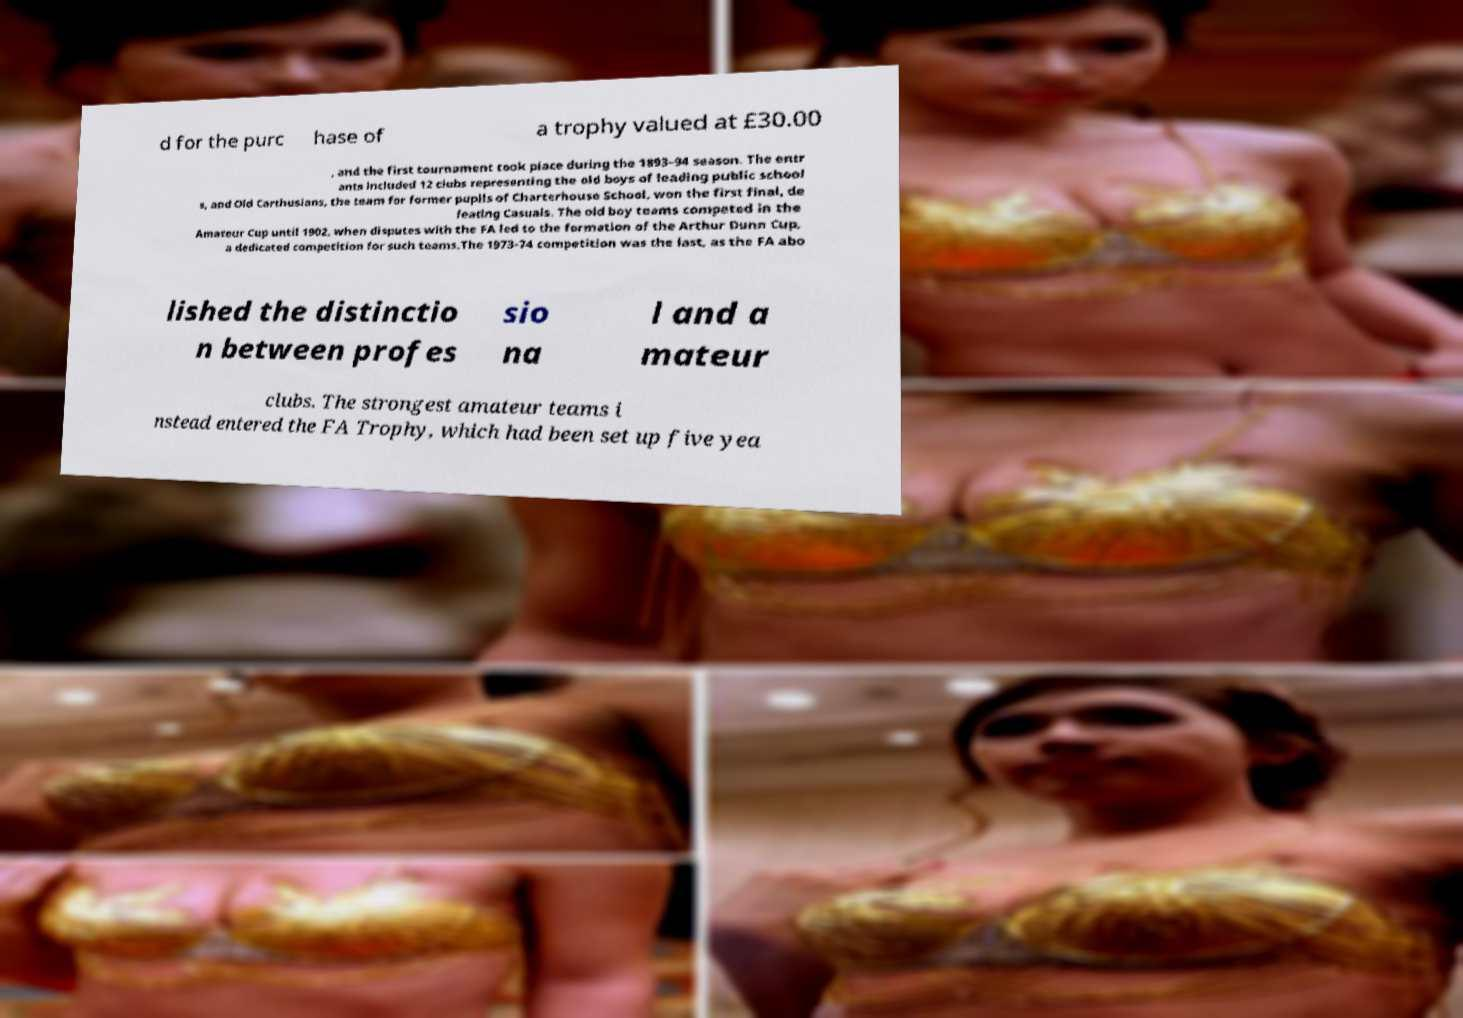Could you extract and type out the text from this image? d for the purc hase of a trophy valued at £30.00 , and the first tournament took place during the 1893–94 season. The entr ants included 12 clubs representing the old boys of leading public school s, and Old Carthusians, the team for former pupils of Charterhouse School, won the first final, de feating Casuals. The old boy teams competed in the Amateur Cup until 1902, when disputes with the FA led to the formation of the Arthur Dunn Cup, a dedicated competition for such teams.The 1973-74 competition was the last, as the FA abo lished the distinctio n between profes sio na l and a mateur clubs. The strongest amateur teams i nstead entered the FA Trophy, which had been set up five yea 